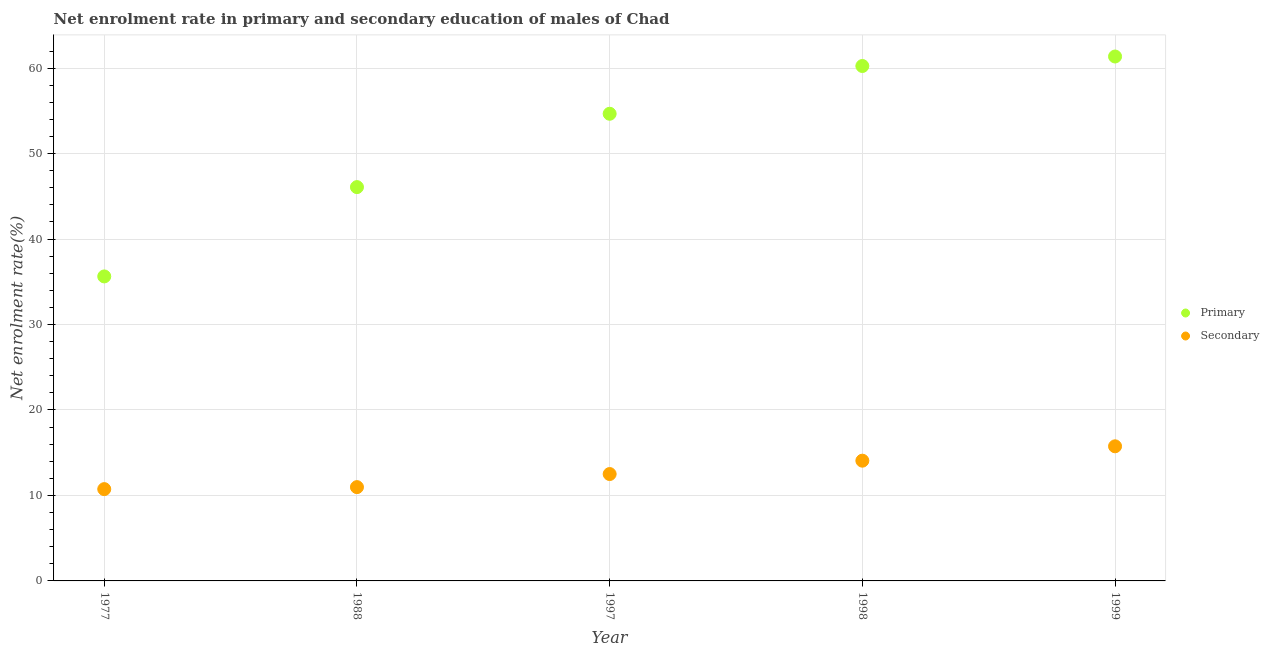How many different coloured dotlines are there?
Your answer should be compact. 2. Is the number of dotlines equal to the number of legend labels?
Make the answer very short. Yes. What is the enrollment rate in secondary education in 1988?
Provide a short and direct response. 10.98. Across all years, what is the maximum enrollment rate in primary education?
Offer a very short reply. 61.36. Across all years, what is the minimum enrollment rate in primary education?
Your answer should be compact. 35.63. In which year was the enrollment rate in secondary education minimum?
Provide a short and direct response. 1977. What is the total enrollment rate in secondary education in the graph?
Offer a terse response. 64.04. What is the difference between the enrollment rate in primary education in 1977 and that in 1999?
Keep it short and to the point. -25.73. What is the difference between the enrollment rate in primary education in 1977 and the enrollment rate in secondary education in 1988?
Keep it short and to the point. 24.65. What is the average enrollment rate in secondary education per year?
Provide a short and direct response. 12.81. In the year 1999, what is the difference between the enrollment rate in secondary education and enrollment rate in primary education?
Provide a succinct answer. -45.61. What is the ratio of the enrollment rate in secondary education in 1997 to that in 1998?
Offer a very short reply. 0.89. Is the enrollment rate in primary education in 1998 less than that in 1999?
Offer a terse response. Yes. Is the difference between the enrollment rate in secondary education in 1988 and 1998 greater than the difference between the enrollment rate in primary education in 1988 and 1998?
Keep it short and to the point. Yes. What is the difference between the highest and the second highest enrollment rate in primary education?
Your response must be concise. 1.11. What is the difference between the highest and the lowest enrollment rate in secondary education?
Ensure brevity in your answer.  5.01. In how many years, is the enrollment rate in primary education greater than the average enrollment rate in primary education taken over all years?
Keep it short and to the point. 3. Does the enrollment rate in primary education monotonically increase over the years?
Keep it short and to the point. Yes. What is the difference between two consecutive major ticks on the Y-axis?
Your response must be concise. 10. Does the graph contain grids?
Ensure brevity in your answer.  Yes. Where does the legend appear in the graph?
Your answer should be compact. Center right. How many legend labels are there?
Ensure brevity in your answer.  2. What is the title of the graph?
Provide a short and direct response. Net enrolment rate in primary and secondary education of males of Chad. Does "Secondary school" appear as one of the legend labels in the graph?
Your answer should be compact. No. What is the label or title of the Y-axis?
Offer a very short reply. Net enrolment rate(%). What is the Net enrolment rate(%) in Primary in 1977?
Give a very brief answer. 35.63. What is the Net enrolment rate(%) of Secondary in 1977?
Ensure brevity in your answer.  10.74. What is the Net enrolment rate(%) of Primary in 1988?
Your answer should be compact. 46.08. What is the Net enrolment rate(%) in Secondary in 1988?
Your response must be concise. 10.98. What is the Net enrolment rate(%) in Primary in 1997?
Your answer should be compact. 54.66. What is the Net enrolment rate(%) in Secondary in 1997?
Your answer should be compact. 12.51. What is the Net enrolment rate(%) of Primary in 1998?
Your answer should be compact. 60.25. What is the Net enrolment rate(%) of Secondary in 1998?
Ensure brevity in your answer.  14.07. What is the Net enrolment rate(%) of Primary in 1999?
Your answer should be compact. 61.36. What is the Net enrolment rate(%) in Secondary in 1999?
Offer a terse response. 15.75. Across all years, what is the maximum Net enrolment rate(%) of Primary?
Your answer should be compact. 61.36. Across all years, what is the maximum Net enrolment rate(%) in Secondary?
Offer a terse response. 15.75. Across all years, what is the minimum Net enrolment rate(%) in Primary?
Your answer should be compact. 35.63. Across all years, what is the minimum Net enrolment rate(%) of Secondary?
Your answer should be compact. 10.74. What is the total Net enrolment rate(%) of Primary in the graph?
Ensure brevity in your answer.  257.99. What is the total Net enrolment rate(%) in Secondary in the graph?
Offer a terse response. 64.04. What is the difference between the Net enrolment rate(%) of Primary in 1977 and that in 1988?
Your answer should be very brief. -10.45. What is the difference between the Net enrolment rate(%) in Secondary in 1977 and that in 1988?
Provide a short and direct response. -0.23. What is the difference between the Net enrolment rate(%) in Primary in 1977 and that in 1997?
Keep it short and to the point. -19.03. What is the difference between the Net enrolment rate(%) of Secondary in 1977 and that in 1997?
Offer a terse response. -1.76. What is the difference between the Net enrolment rate(%) of Primary in 1977 and that in 1998?
Ensure brevity in your answer.  -24.62. What is the difference between the Net enrolment rate(%) of Secondary in 1977 and that in 1998?
Give a very brief answer. -3.33. What is the difference between the Net enrolment rate(%) of Primary in 1977 and that in 1999?
Provide a short and direct response. -25.73. What is the difference between the Net enrolment rate(%) in Secondary in 1977 and that in 1999?
Offer a terse response. -5.01. What is the difference between the Net enrolment rate(%) of Primary in 1988 and that in 1997?
Provide a succinct answer. -8.58. What is the difference between the Net enrolment rate(%) in Secondary in 1988 and that in 1997?
Your answer should be very brief. -1.53. What is the difference between the Net enrolment rate(%) of Primary in 1988 and that in 1998?
Offer a terse response. -14.17. What is the difference between the Net enrolment rate(%) in Secondary in 1988 and that in 1998?
Give a very brief answer. -3.09. What is the difference between the Net enrolment rate(%) in Primary in 1988 and that in 1999?
Give a very brief answer. -15.28. What is the difference between the Net enrolment rate(%) in Secondary in 1988 and that in 1999?
Make the answer very short. -4.78. What is the difference between the Net enrolment rate(%) in Primary in 1997 and that in 1998?
Provide a succinct answer. -5.59. What is the difference between the Net enrolment rate(%) of Secondary in 1997 and that in 1998?
Your answer should be compact. -1.56. What is the difference between the Net enrolment rate(%) in Primary in 1997 and that in 1999?
Offer a terse response. -6.7. What is the difference between the Net enrolment rate(%) in Secondary in 1997 and that in 1999?
Ensure brevity in your answer.  -3.25. What is the difference between the Net enrolment rate(%) of Primary in 1998 and that in 1999?
Offer a very short reply. -1.11. What is the difference between the Net enrolment rate(%) in Secondary in 1998 and that in 1999?
Keep it short and to the point. -1.68. What is the difference between the Net enrolment rate(%) of Primary in 1977 and the Net enrolment rate(%) of Secondary in 1988?
Provide a succinct answer. 24.65. What is the difference between the Net enrolment rate(%) of Primary in 1977 and the Net enrolment rate(%) of Secondary in 1997?
Make the answer very short. 23.12. What is the difference between the Net enrolment rate(%) in Primary in 1977 and the Net enrolment rate(%) in Secondary in 1998?
Provide a short and direct response. 21.56. What is the difference between the Net enrolment rate(%) of Primary in 1977 and the Net enrolment rate(%) of Secondary in 1999?
Provide a short and direct response. 19.88. What is the difference between the Net enrolment rate(%) of Primary in 1988 and the Net enrolment rate(%) of Secondary in 1997?
Your response must be concise. 33.57. What is the difference between the Net enrolment rate(%) of Primary in 1988 and the Net enrolment rate(%) of Secondary in 1998?
Provide a short and direct response. 32.01. What is the difference between the Net enrolment rate(%) of Primary in 1988 and the Net enrolment rate(%) of Secondary in 1999?
Offer a terse response. 30.33. What is the difference between the Net enrolment rate(%) in Primary in 1997 and the Net enrolment rate(%) in Secondary in 1998?
Ensure brevity in your answer.  40.59. What is the difference between the Net enrolment rate(%) in Primary in 1997 and the Net enrolment rate(%) in Secondary in 1999?
Provide a succinct answer. 38.91. What is the difference between the Net enrolment rate(%) in Primary in 1998 and the Net enrolment rate(%) in Secondary in 1999?
Provide a short and direct response. 44.5. What is the average Net enrolment rate(%) of Primary per year?
Offer a terse response. 51.6. What is the average Net enrolment rate(%) of Secondary per year?
Ensure brevity in your answer.  12.81. In the year 1977, what is the difference between the Net enrolment rate(%) in Primary and Net enrolment rate(%) in Secondary?
Offer a terse response. 24.89. In the year 1988, what is the difference between the Net enrolment rate(%) of Primary and Net enrolment rate(%) of Secondary?
Offer a very short reply. 35.11. In the year 1997, what is the difference between the Net enrolment rate(%) of Primary and Net enrolment rate(%) of Secondary?
Your response must be concise. 42.16. In the year 1998, what is the difference between the Net enrolment rate(%) in Primary and Net enrolment rate(%) in Secondary?
Offer a terse response. 46.18. In the year 1999, what is the difference between the Net enrolment rate(%) of Primary and Net enrolment rate(%) of Secondary?
Keep it short and to the point. 45.61. What is the ratio of the Net enrolment rate(%) in Primary in 1977 to that in 1988?
Your response must be concise. 0.77. What is the ratio of the Net enrolment rate(%) of Secondary in 1977 to that in 1988?
Provide a short and direct response. 0.98. What is the ratio of the Net enrolment rate(%) of Primary in 1977 to that in 1997?
Your answer should be compact. 0.65. What is the ratio of the Net enrolment rate(%) of Secondary in 1977 to that in 1997?
Provide a succinct answer. 0.86. What is the ratio of the Net enrolment rate(%) in Primary in 1977 to that in 1998?
Offer a very short reply. 0.59. What is the ratio of the Net enrolment rate(%) of Secondary in 1977 to that in 1998?
Your answer should be very brief. 0.76. What is the ratio of the Net enrolment rate(%) of Primary in 1977 to that in 1999?
Keep it short and to the point. 0.58. What is the ratio of the Net enrolment rate(%) of Secondary in 1977 to that in 1999?
Provide a short and direct response. 0.68. What is the ratio of the Net enrolment rate(%) of Primary in 1988 to that in 1997?
Offer a terse response. 0.84. What is the ratio of the Net enrolment rate(%) of Secondary in 1988 to that in 1997?
Offer a very short reply. 0.88. What is the ratio of the Net enrolment rate(%) of Primary in 1988 to that in 1998?
Offer a terse response. 0.76. What is the ratio of the Net enrolment rate(%) of Secondary in 1988 to that in 1998?
Offer a terse response. 0.78. What is the ratio of the Net enrolment rate(%) in Primary in 1988 to that in 1999?
Keep it short and to the point. 0.75. What is the ratio of the Net enrolment rate(%) in Secondary in 1988 to that in 1999?
Your answer should be compact. 0.7. What is the ratio of the Net enrolment rate(%) of Primary in 1997 to that in 1998?
Your answer should be compact. 0.91. What is the ratio of the Net enrolment rate(%) in Secondary in 1997 to that in 1998?
Your response must be concise. 0.89. What is the ratio of the Net enrolment rate(%) of Primary in 1997 to that in 1999?
Your response must be concise. 0.89. What is the ratio of the Net enrolment rate(%) in Secondary in 1997 to that in 1999?
Provide a succinct answer. 0.79. What is the ratio of the Net enrolment rate(%) in Primary in 1998 to that in 1999?
Provide a succinct answer. 0.98. What is the ratio of the Net enrolment rate(%) of Secondary in 1998 to that in 1999?
Your answer should be compact. 0.89. What is the difference between the highest and the second highest Net enrolment rate(%) of Primary?
Provide a short and direct response. 1.11. What is the difference between the highest and the second highest Net enrolment rate(%) in Secondary?
Give a very brief answer. 1.68. What is the difference between the highest and the lowest Net enrolment rate(%) in Primary?
Provide a succinct answer. 25.73. What is the difference between the highest and the lowest Net enrolment rate(%) of Secondary?
Your response must be concise. 5.01. 